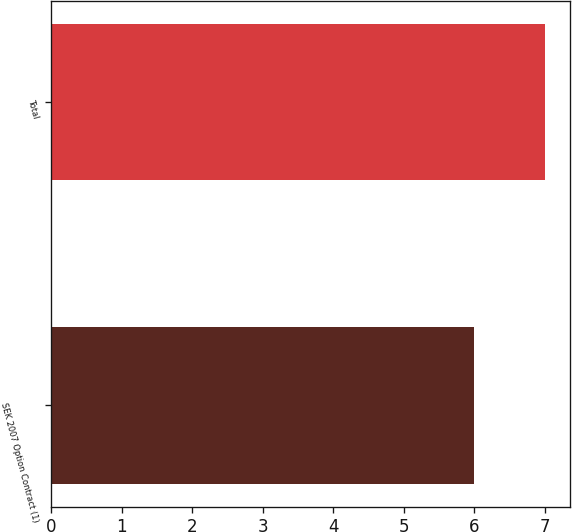Convert chart to OTSL. <chart><loc_0><loc_0><loc_500><loc_500><bar_chart><fcel>SEK 2007 Option Contract (1)<fcel>Total<nl><fcel>6<fcel>7<nl></chart> 